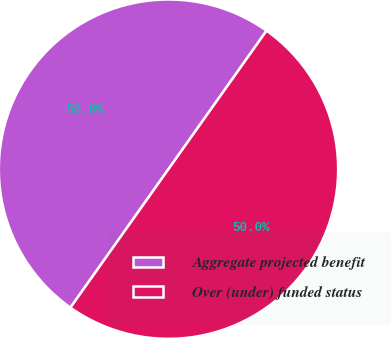Convert chart. <chart><loc_0><loc_0><loc_500><loc_500><pie_chart><fcel>Aggregate projected benefit<fcel>Over (under) funded status<nl><fcel>50.0%<fcel>50.0%<nl></chart> 